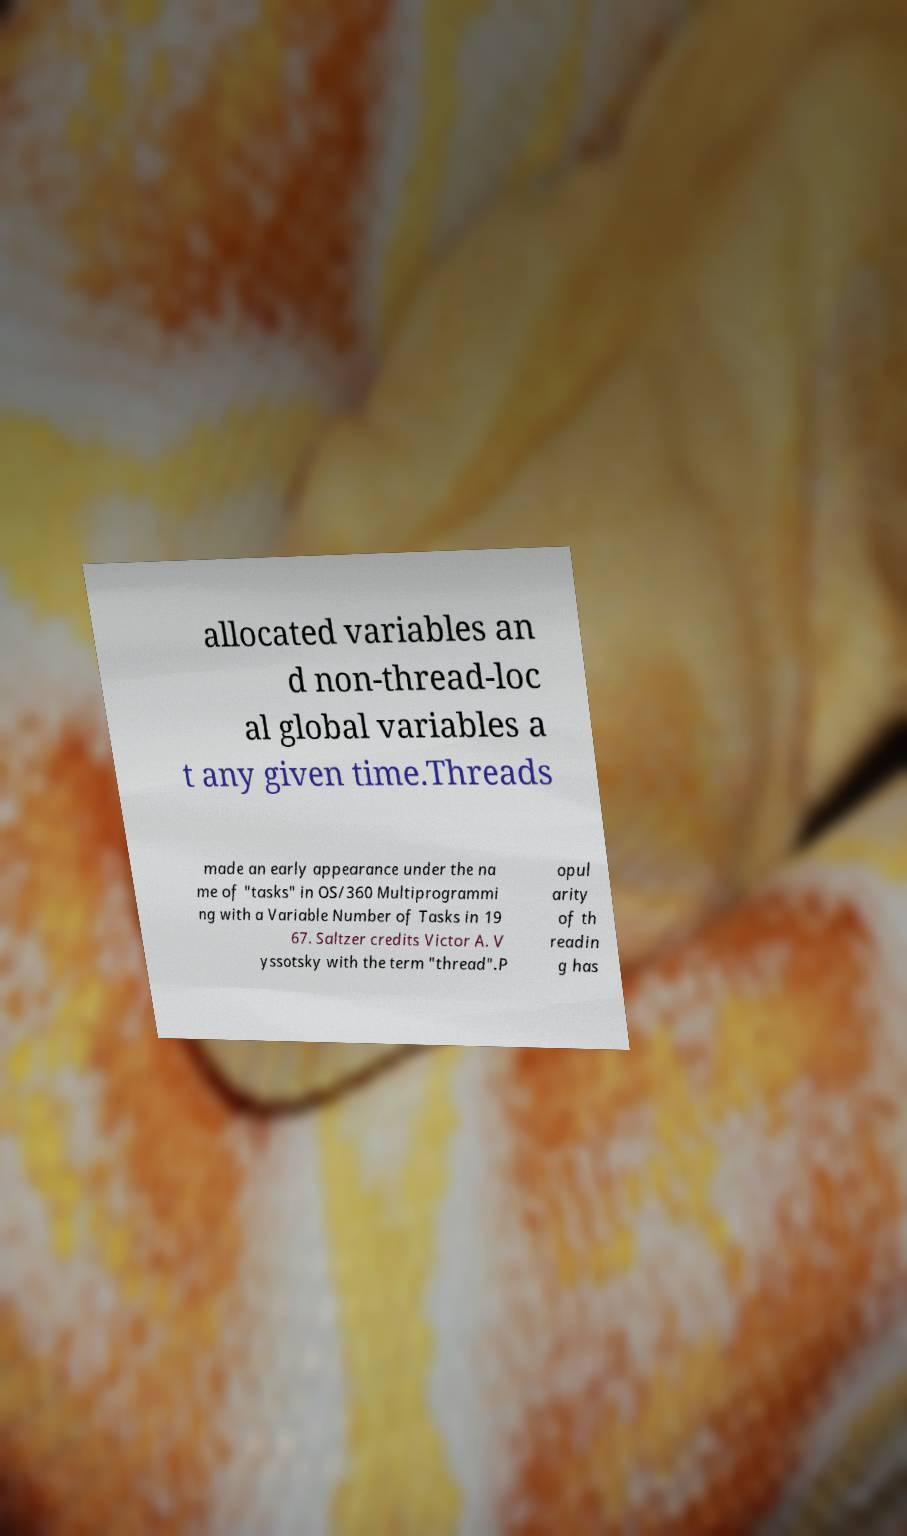Could you extract and type out the text from this image? allocated variables an d non-thread-loc al global variables a t any given time.Threads made an early appearance under the na me of "tasks" in OS/360 Multiprogrammi ng with a Variable Number of Tasks in 19 67. Saltzer credits Victor A. V yssotsky with the term "thread".P opul arity of th readin g has 